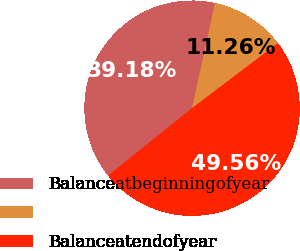<chart> <loc_0><loc_0><loc_500><loc_500><pie_chart><fcel>Balanceatbeginningofyear<fcel>Unnamed: 1<fcel>Balanceatendofyear<nl><fcel>39.18%<fcel>11.26%<fcel>49.56%<nl></chart> 